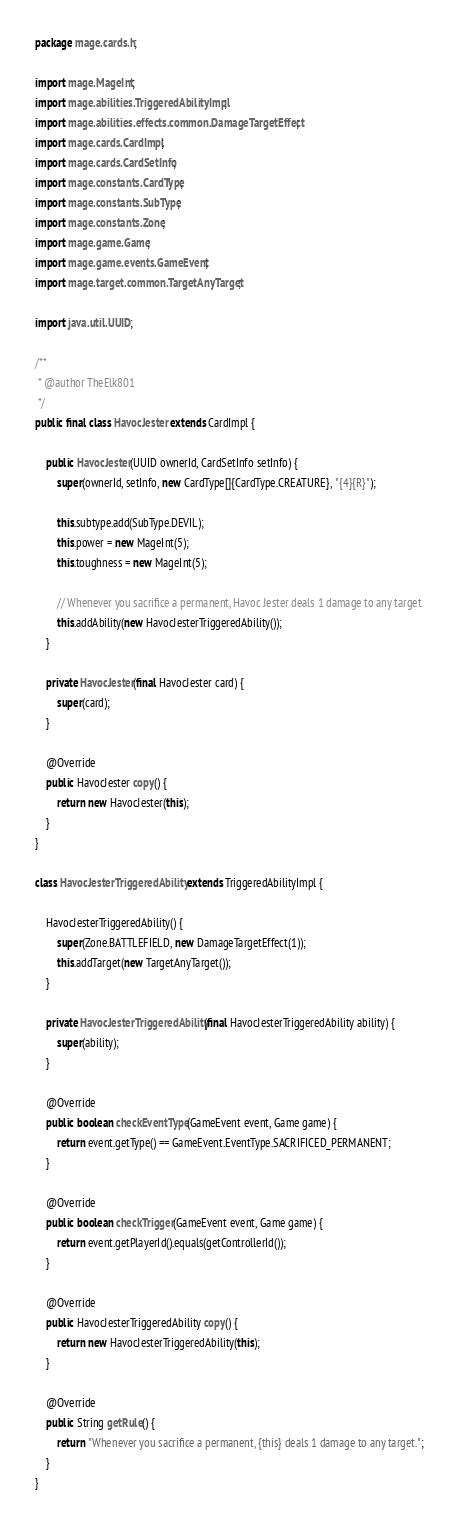Convert code to text. <code><loc_0><loc_0><loc_500><loc_500><_Java_>package mage.cards.h;

import mage.MageInt;
import mage.abilities.TriggeredAbilityImpl;
import mage.abilities.effects.common.DamageTargetEffect;
import mage.cards.CardImpl;
import mage.cards.CardSetInfo;
import mage.constants.CardType;
import mage.constants.SubType;
import mage.constants.Zone;
import mage.game.Game;
import mage.game.events.GameEvent;
import mage.target.common.TargetAnyTarget;

import java.util.UUID;

/**
 * @author TheElk801
 */
public final class HavocJester extends CardImpl {

    public HavocJester(UUID ownerId, CardSetInfo setInfo) {
        super(ownerId, setInfo, new CardType[]{CardType.CREATURE}, "{4}{R}");

        this.subtype.add(SubType.DEVIL);
        this.power = new MageInt(5);
        this.toughness = new MageInt(5);

        // Whenever you sacrifice a permanent, Havoc Jester deals 1 damage to any target.
        this.addAbility(new HavocJesterTriggeredAbility());
    }

    private HavocJester(final HavocJester card) {
        super(card);
    }

    @Override
    public HavocJester copy() {
        return new HavocJester(this);
    }
}

class HavocJesterTriggeredAbility extends TriggeredAbilityImpl {

    HavocJesterTriggeredAbility() {
        super(Zone.BATTLEFIELD, new DamageTargetEffect(1));
        this.addTarget(new TargetAnyTarget());
    }

    private HavocJesterTriggeredAbility(final HavocJesterTriggeredAbility ability) {
        super(ability);
    }

    @Override
    public boolean checkEventType(GameEvent event, Game game) {
        return event.getType() == GameEvent.EventType.SACRIFICED_PERMANENT;
    }

    @Override
    public boolean checkTrigger(GameEvent event, Game game) {
        return event.getPlayerId().equals(getControllerId());
    }

    @Override
    public HavocJesterTriggeredAbility copy() {
        return new HavocJesterTriggeredAbility(this);
    }

    @Override
    public String getRule() {
        return "Whenever you sacrifice a permanent, {this} deals 1 damage to any target.";
    }
}
</code> 